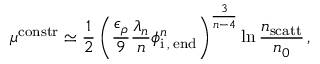<formula> <loc_0><loc_0><loc_500><loc_500>\mu ^ { c o n s t r } \simeq \frac { 1 } { 2 } \left ( \frac { \epsilon _ { \rho } } { 9 } \frac { \lambda _ { n } } { n } \phi _ { i \, , \, e n d } ^ { n } \right ) ^ { \frac { 3 } { n - 4 } } \ln \frac { n _ { s c a t t } } { n _ { 0 } } \, ,</formula> 